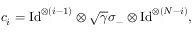Convert formula to latex. <formula><loc_0><loc_0><loc_500><loc_500>{ c } _ { i } = I d ^ { \otimes ( i - 1 ) } \otimes \sqrt { \gamma } \sigma _ { - } \otimes I d ^ { \otimes ( N - i ) } ,</formula> 